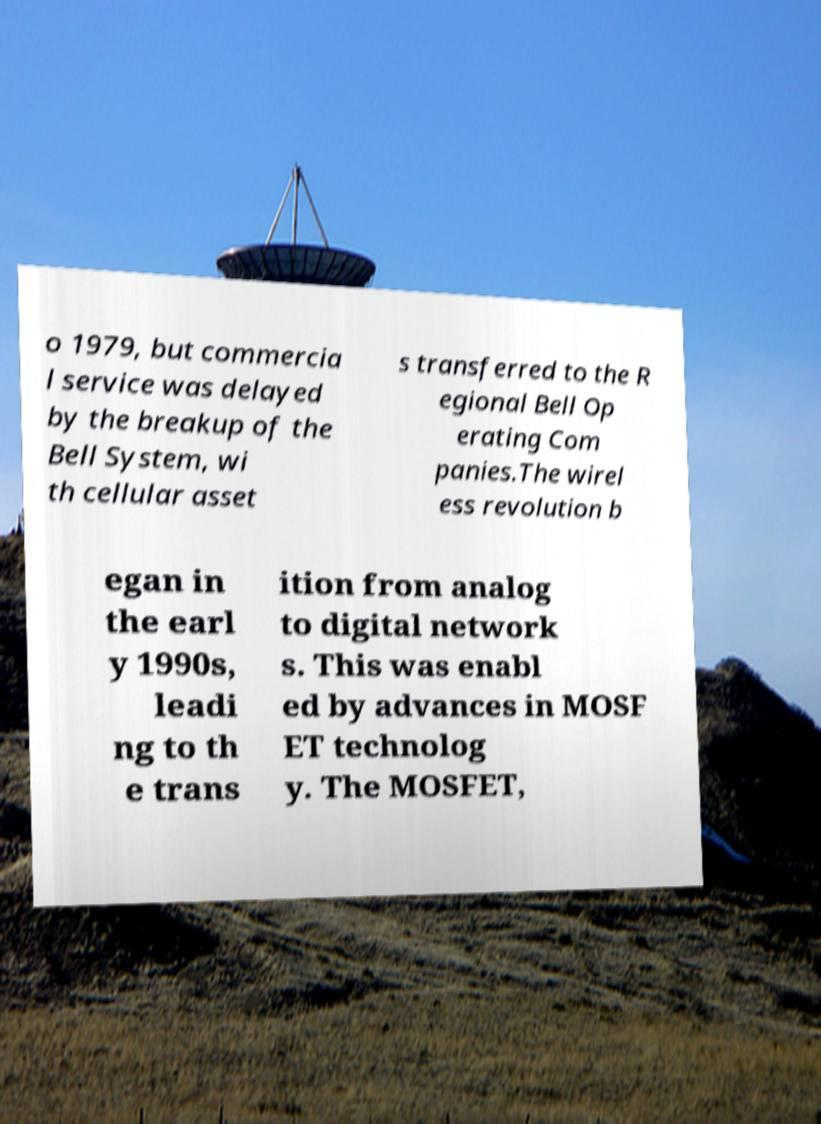Can you read and provide the text displayed in the image?This photo seems to have some interesting text. Can you extract and type it out for me? o 1979, but commercia l service was delayed by the breakup of the Bell System, wi th cellular asset s transferred to the R egional Bell Op erating Com panies.The wirel ess revolution b egan in the earl y 1990s, leadi ng to th e trans ition from analog to digital network s. This was enabl ed by advances in MOSF ET technolog y. The MOSFET, 